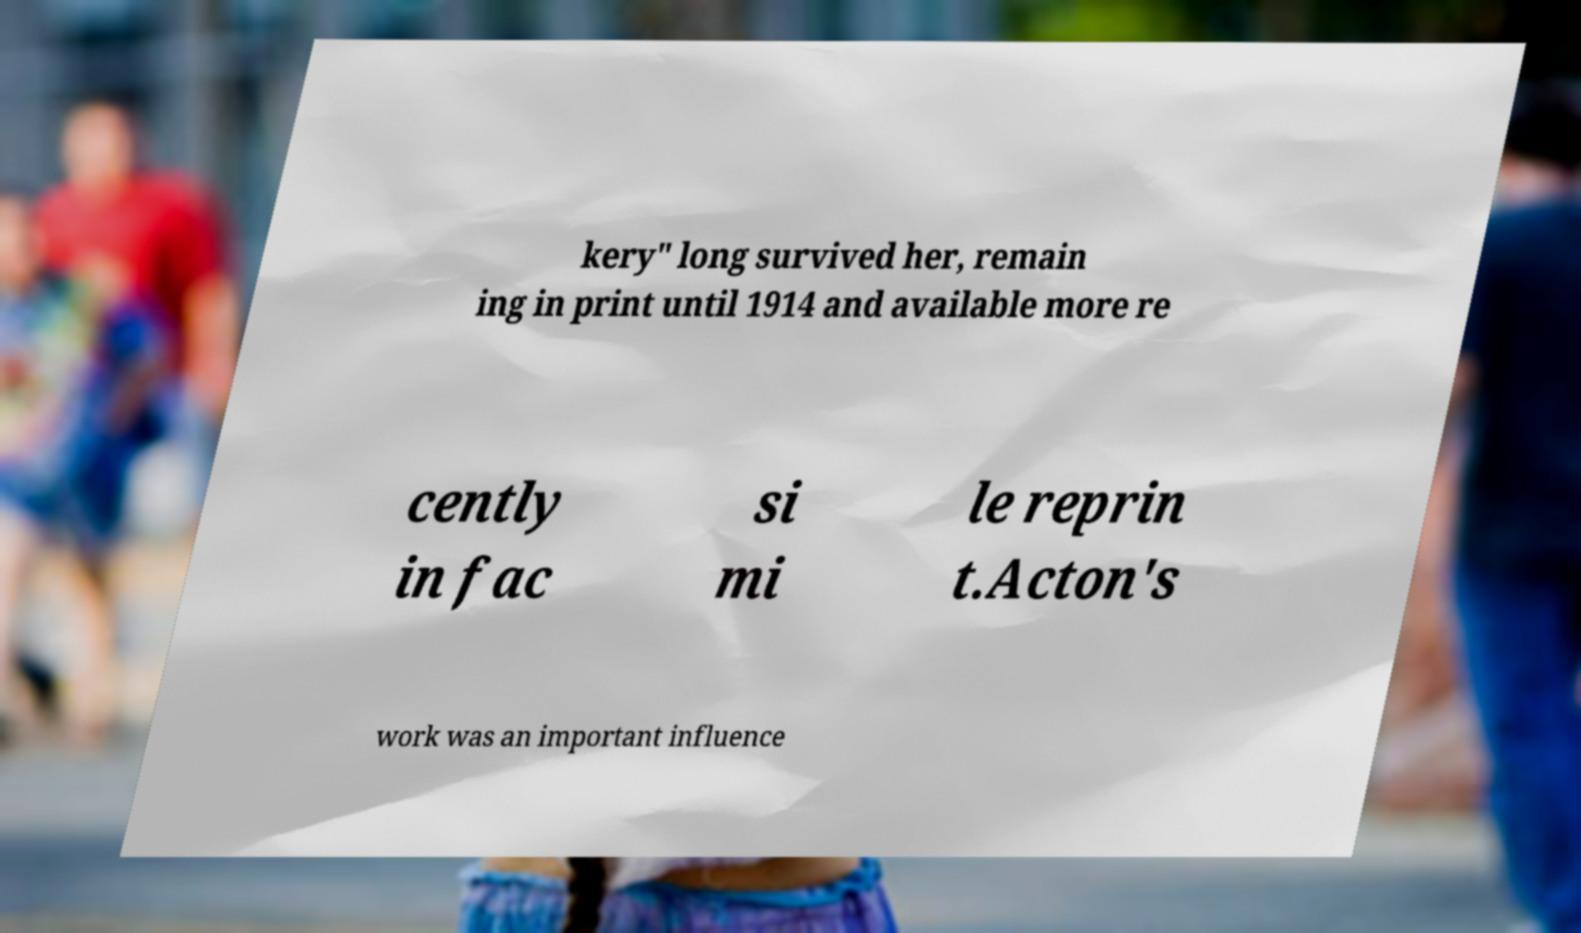Could you extract and type out the text from this image? kery" long survived her, remain ing in print until 1914 and available more re cently in fac si mi le reprin t.Acton's work was an important influence 